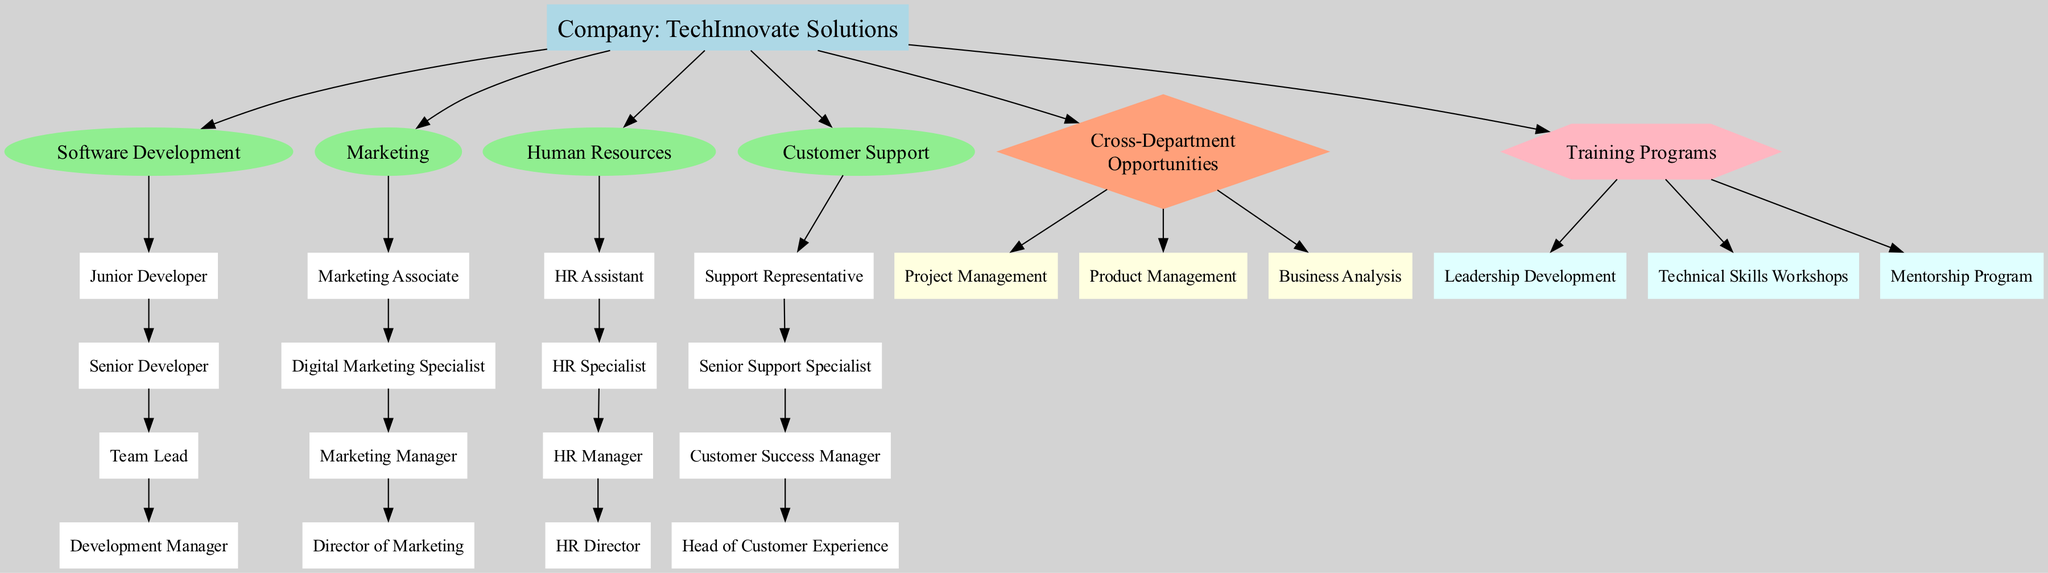What is the top position in the Human Resources department? In the Organizational Chart, the Human Resources department lists its positions in hierarchical order. The last position mentioned is "HR Director," which occupies the top spot in that department.
Answer: HR Director How many positions are there in the Software Development department? The Software Development department has four listed positions: Junior Developer, Senior Developer, Team Lead, and Development Manager. Counting these positions gives us a total of four.
Answer: 4 Which department has the position of "Customer Success Manager"? By examining the diagram, the "Customer Success Manager" position is found within the Customer Support department, where it is positioned after "Senior Support Specialist" and before "Head of Customer Experience."
Answer: Customer Support What cross-department opportunity is available? The diagram lists multiple cross-departmental opportunities. One example is "Project Management," which indicates a potential growth path outside a specific department.
Answer: Project Management What training program focuses on enhancing leadership skills? Among the training programs, "Leadership Development" is explicitly designed to enhance leadership skills, as indicated by its name.
Answer: Leadership Development Which position has the current employee's designation? The diagram highlights the current position of the part-time employee as "Support Representative." This specific designation is marked in a different color indicating that it is the employee's current role.
Answer: Support Representative What is the relationship between the Marketing Manager and the Director of Marketing? In the diagram, "Marketing Manager" is positioned directly below "Director of Marketing," indicating that the Marketing Manager reports to the Director of Marketing and is part of the same department's hierarchy.
Answer: Reports to List one potential career path from the position of Junior Developer. Analyzing the Software Development department’s hierarchy, the next potential career advancement after "Junior Developer" is "Senior Developer," showing a clear upward trajectory in this career path.
Answer: Senior Developer How many total departments are represented in the diagram? The diagram outlines four distinct departments: Software Development, Marketing, Human Resources, and Customer Support. Counting these departments gives a total of four departments.
Answer: 4 